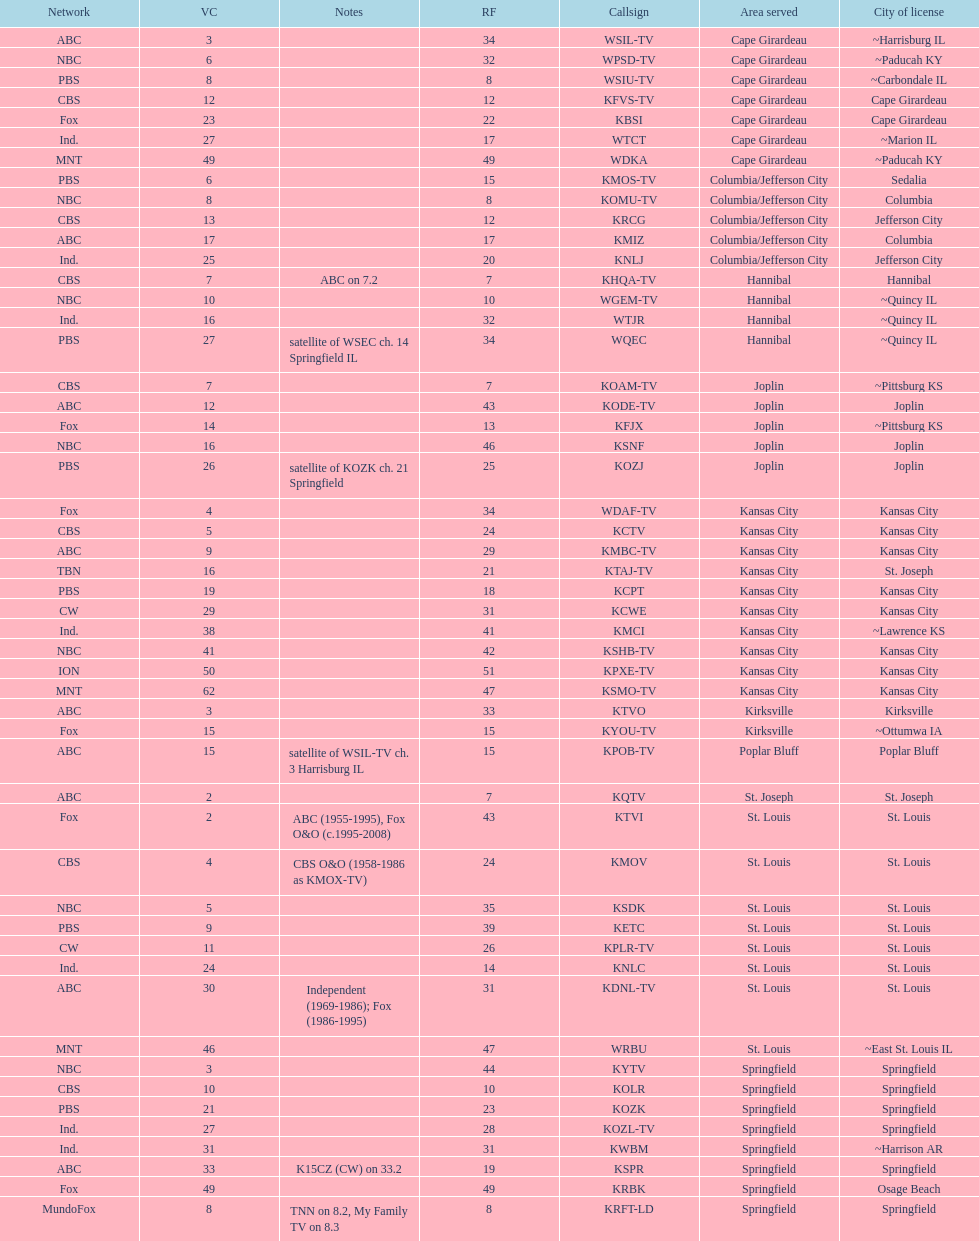How many of these missouri tv stations are actually licensed in a city in illinois (il)? 7. 